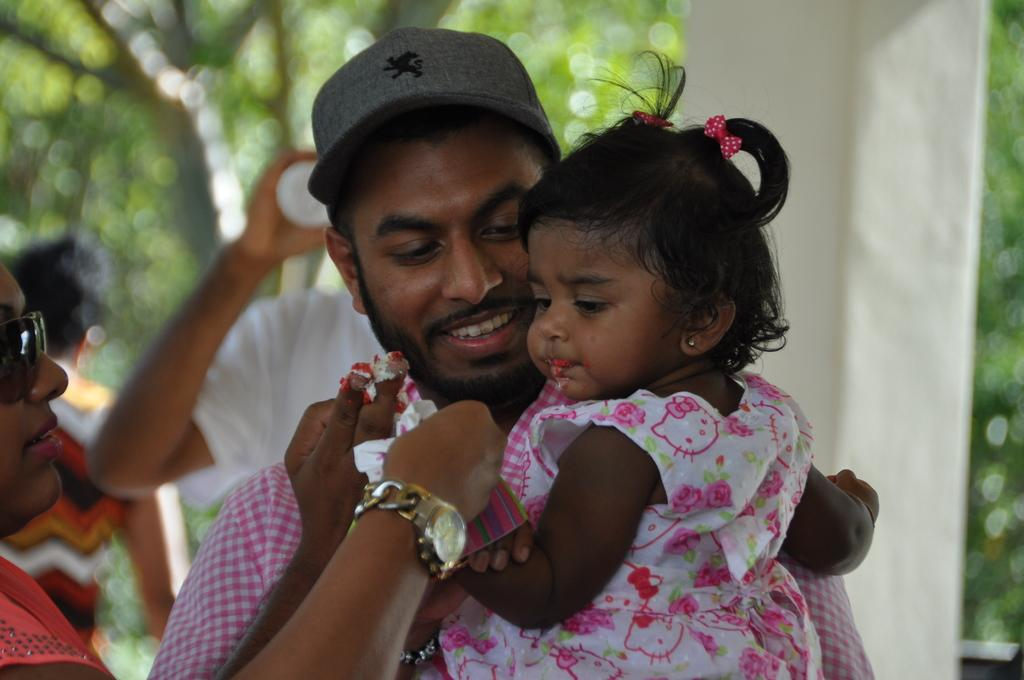What is the main subject in the front of the image? There is a group of people in the front of the image. What can be seen in the background of the image? There are trees in the background of the image. How would you describe the background in the image? The background is slightly blurred. Where is the drawer located in the image? There is no drawer present in the image. How does the group of people rest in the image? The image does not show the group of people resting; they are standing or walking. 